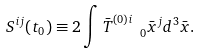<formula> <loc_0><loc_0><loc_500><loc_500>S ^ { i j } ( t _ { 0 } ) \equiv 2 \int \bar { T } ^ { ( 0 ) i } _ { \quad 0 } \bar { x } ^ { j } d ^ { 3 } \bar { x } .</formula> 